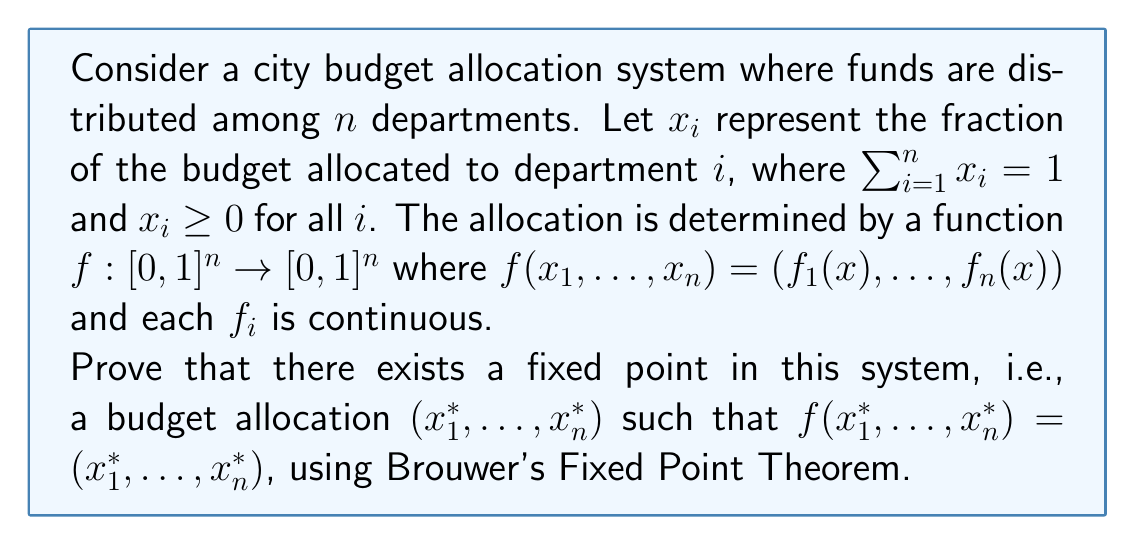What is the answer to this math problem? To prove the existence of a fixed point in this budget allocation system, we will use Brouwer's Fixed Point Theorem. Let's approach this step-by-step:

1) First, let's define our domain. The set of all possible budget allocations is:

   $$\Delta_n = \{(x_1, ..., x_n) \in [0,1]^n : \sum_{i=1}^n x_i = 1\}$$

   This is known as the standard (n-1)-simplex.

2) We need to show that $\Delta_n$ satisfies the conditions for Brouwer's Fixed Point Theorem:
   
   a) $\Delta_n$ is non-empty: It clearly contains points, e.g., $(1/n, ..., 1/n)$.
   b) $\Delta_n$ is compact: It's closed (contains its boundary) and bounded in $\mathbb{R}^n$.
   c) $\Delta_n$ is convex: For any two points in $\Delta_n$, the line segment between them is also in $\Delta_n$.

3) Now, we need to show that $f: \Delta_n \rightarrow \Delta_n$. This means:
   
   a) $\sum_{i=1}^n f_i(x) = 1$ for all $x \in \Delta_n$
   b) $f_i(x) \geq 0$ for all $i$ and all $x \in \Delta_n$

   These conditions are given in the problem statement.

4) Finally, we need to show that $f$ is continuous. This is also given in the problem statement.

5) With all these conditions satisfied, we can apply Brouwer's Fixed Point Theorem, which states:

   Every continuous function from a convex compact subset of a Euclidean space to itself has a fixed point.

6) Therefore, there exists a point $x^* = (x_1^*, ..., x_n^*) \in \Delta_n$ such that $f(x^*) = x^*$.

This fixed point $x^*$ represents a budget allocation where the output of the allocation function $f$ is the same as its input, meaning no department's budget would change under this allocation.
Answer: By Brouwer's Fixed Point Theorem, there exists a fixed point $x^* = (x_1^*, ..., x_n^*) \in \Delta_n$ such that $f(x^*) = x^*$, representing a stable budget allocation. 